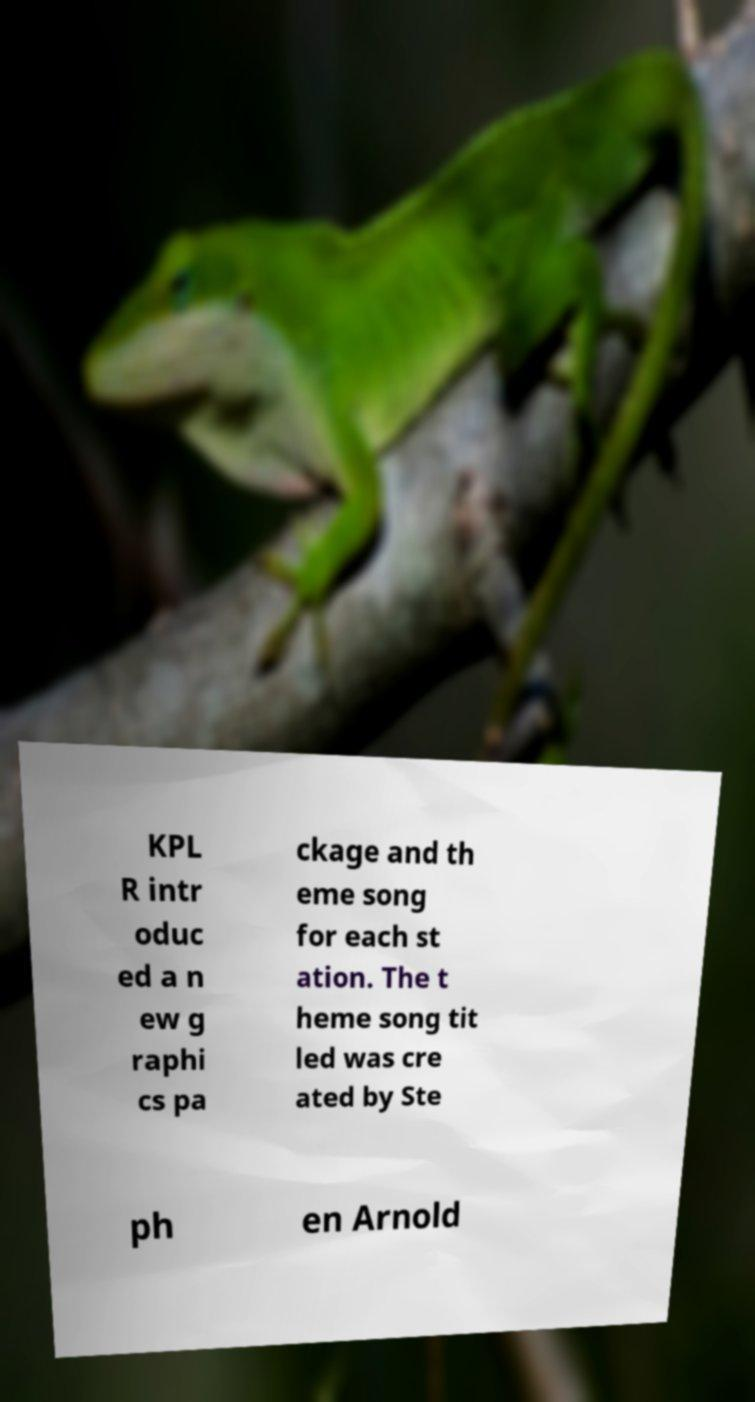There's text embedded in this image that I need extracted. Can you transcribe it verbatim? KPL R intr oduc ed a n ew g raphi cs pa ckage and th eme song for each st ation. The t heme song tit led was cre ated by Ste ph en Arnold 